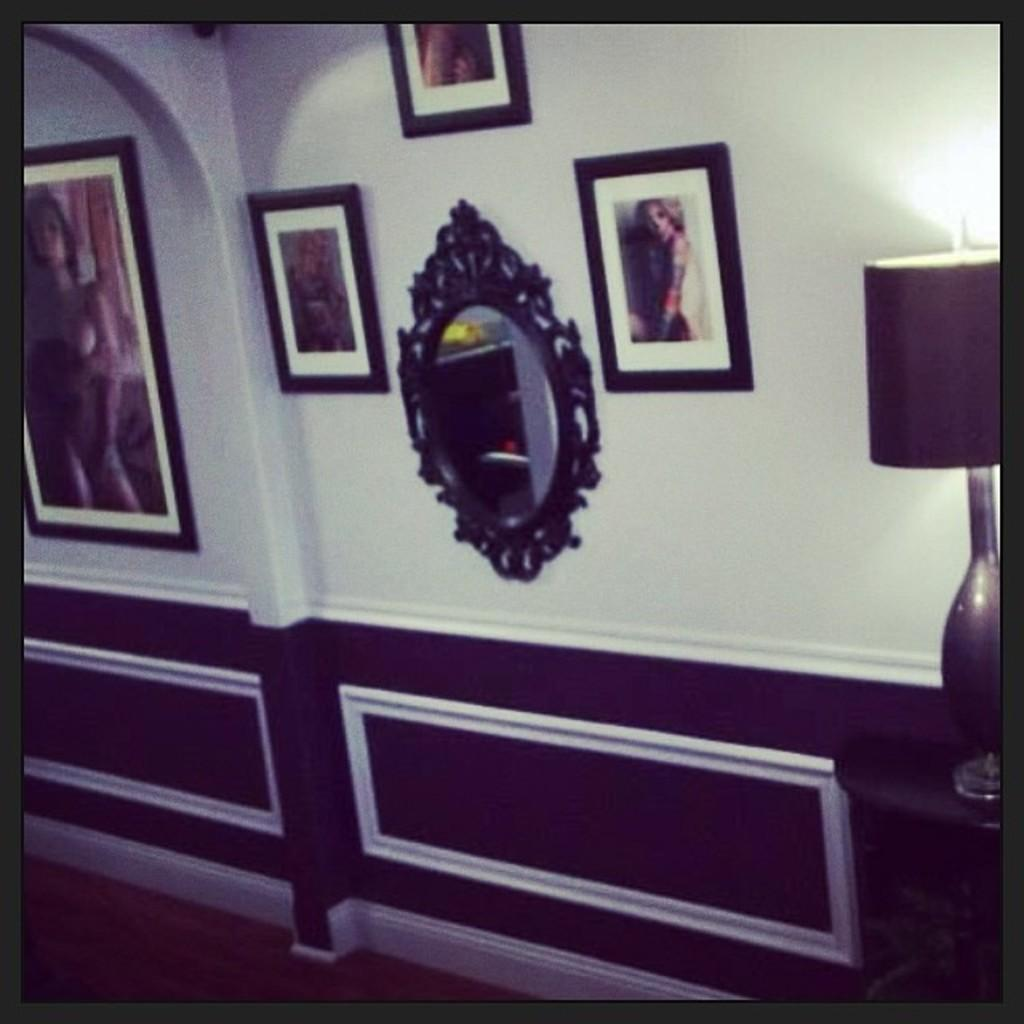What type of objects are hanging on the wall in the image? There are photo frames on the wall. What other object can be seen on the wall in the image? There is a mirror on the wall. What can be seen on the right side of the image? There is a lamp on the right side of the image. What type of bread is being spread with butter in the image? There is no bread or butter present in the image. Which type of berry is growing on the wall in the image? There are no berries growing on the wall in the image. 